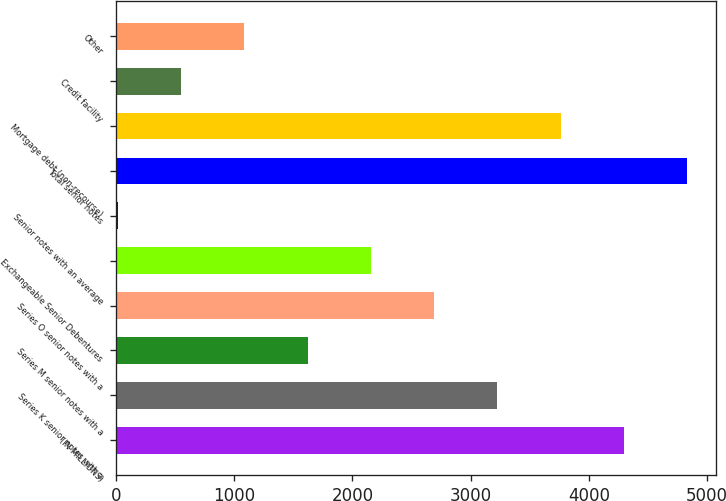Convert chart to OTSL. <chart><loc_0><loc_0><loc_500><loc_500><bar_chart><fcel>(IN MILLIONS)<fcel>Series K senior notes with a<fcel>Series M senior notes with a<fcel>Series O senior notes with a<fcel>Exchangeable Senior Debentures<fcel>Senior notes with an average<fcel>Total senior notes<fcel>Mortgage debt (non-recourse)<fcel>Credit facility<fcel>Other<nl><fcel>4298.6<fcel>3227.2<fcel>1620.1<fcel>2691.5<fcel>2155.8<fcel>13<fcel>4834.3<fcel>3762.9<fcel>548.7<fcel>1084.4<nl></chart> 